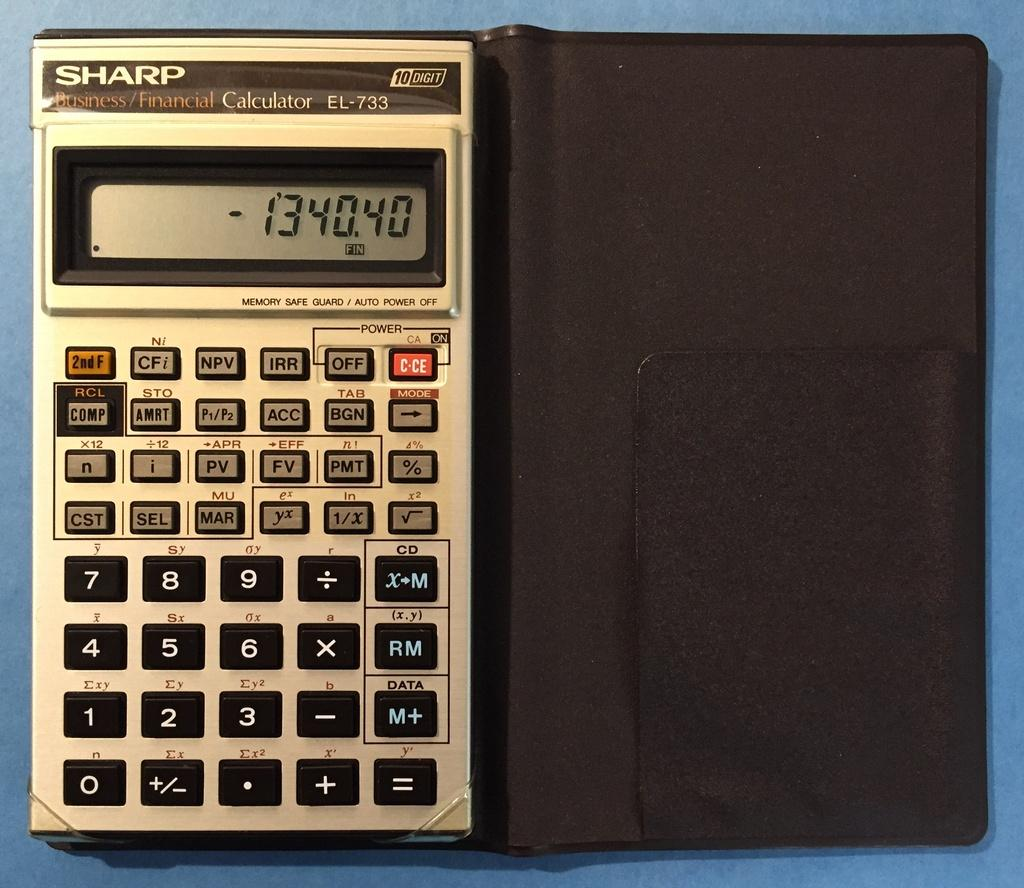Provide a one-sentence caption for the provided image. Old Sharp Calculator with the numbers "-1340.40" on the screen. 